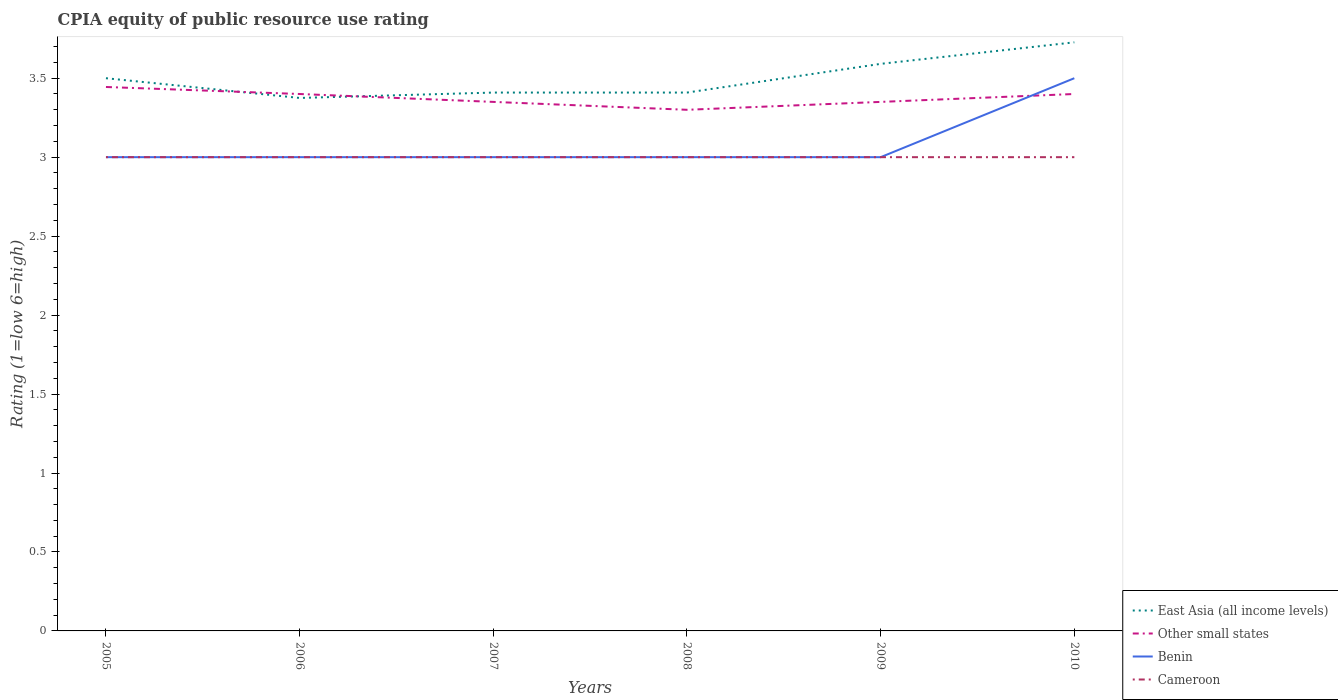How many different coloured lines are there?
Provide a short and direct response. 4. Does the line corresponding to Cameroon intersect with the line corresponding to Benin?
Give a very brief answer. Yes. Is the number of lines equal to the number of legend labels?
Your answer should be compact. Yes. In which year was the CPIA rating in East Asia (all income levels) maximum?
Offer a terse response. 2006. What is the difference between the highest and the second highest CPIA rating in Other small states?
Provide a short and direct response. 0.14. Is the CPIA rating in Cameroon strictly greater than the CPIA rating in East Asia (all income levels) over the years?
Your answer should be compact. Yes. What is the difference between two consecutive major ticks on the Y-axis?
Provide a short and direct response. 0.5. Are the values on the major ticks of Y-axis written in scientific E-notation?
Your response must be concise. No. How many legend labels are there?
Offer a terse response. 4. How are the legend labels stacked?
Give a very brief answer. Vertical. What is the title of the graph?
Make the answer very short. CPIA equity of public resource use rating. Does "Thailand" appear as one of the legend labels in the graph?
Your answer should be compact. No. What is the label or title of the X-axis?
Offer a very short reply. Years. What is the label or title of the Y-axis?
Your answer should be compact. Rating (1=low 6=high). What is the Rating (1=low 6=high) of Other small states in 2005?
Your answer should be compact. 3.44. What is the Rating (1=low 6=high) in East Asia (all income levels) in 2006?
Offer a very short reply. 3.38. What is the Rating (1=low 6=high) in Cameroon in 2006?
Offer a terse response. 3. What is the Rating (1=low 6=high) of East Asia (all income levels) in 2007?
Your answer should be very brief. 3.41. What is the Rating (1=low 6=high) in Other small states in 2007?
Offer a very short reply. 3.35. What is the Rating (1=low 6=high) of Cameroon in 2007?
Ensure brevity in your answer.  3. What is the Rating (1=low 6=high) in East Asia (all income levels) in 2008?
Give a very brief answer. 3.41. What is the Rating (1=low 6=high) of Other small states in 2008?
Ensure brevity in your answer.  3.3. What is the Rating (1=low 6=high) in Benin in 2008?
Offer a terse response. 3. What is the Rating (1=low 6=high) in Cameroon in 2008?
Your answer should be compact. 3. What is the Rating (1=low 6=high) of East Asia (all income levels) in 2009?
Provide a short and direct response. 3.59. What is the Rating (1=low 6=high) of Other small states in 2009?
Keep it short and to the point. 3.35. What is the Rating (1=low 6=high) in Cameroon in 2009?
Offer a terse response. 3. What is the Rating (1=low 6=high) in East Asia (all income levels) in 2010?
Offer a very short reply. 3.73. What is the Rating (1=low 6=high) of Other small states in 2010?
Keep it short and to the point. 3.4. What is the Rating (1=low 6=high) in Cameroon in 2010?
Offer a very short reply. 3. Across all years, what is the maximum Rating (1=low 6=high) in East Asia (all income levels)?
Your answer should be very brief. 3.73. Across all years, what is the maximum Rating (1=low 6=high) of Other small states?
Offer a terse response. 3.44. Across all years, what is the maximum Rating (1=low 6=high) of Cameroon?
Your answer should be compact. 3. Across all years, what is the minimum Rating (1=low 6=high) of East Asia (all income levels)?
Offer a terse response. 3.38. Across all years, what is the minimum Rating (1=low 6=high) of Other small states?
Your answer should be very brief. 3.3. Across all years, what is the minimum Rating (1=low 6=high) of Benin?
Provide a succinct answer. 3. What is the total Rating (1=low 6=high) of East Asia (all income levels) in the graph?
Your answer should be compact. 21.01. What is the total Rating (1=low 6=high) in Other small states in the graph?
Your answer should be very brief. 20.24. What is the total Rating (1=low 6=high) of Benin in the graph?
Your response must be concise. 18.5. What is the total Rating (1=low 6=high) in Cameroon in the graph?
Keep it short and to the point. 18. What is the difference between the Rating (1=low 6=high) in East Asia (all income levels) in 2005 and that in 2006?
Provide a succinct answer. 0.12. What is the difference between the Rating (1=low 6=high) of Other small states in 2005 and that in 2006?
Ensure brevity in your answer.  0.04. What is the difference between the Rating (1=low 6=high) of East Asia (all income levels) in 2005 and that in 2007?
Give a very brief answer. 0.09. What is the difference between the Rating (1=low 6=high) in Other small states in 2005 and that in 2007?
Offer a terse response. 0.09. What is the difference between the Rating (1=low 6=high) of Benin in 2005 and that in 2007?
Provide a short and direct response. 0. What is the difference between the Rating (1=low 6=high) of Cameroon in 2005 and that in 2007?
Offer a very short reply. 0. What is the difference between the Rating (1=low 6=high) in East Asia (all income levels) in 2005 and that in 2008?
Ensure brevity in your answer.  0.09. What is the difference between the Rating (1=low 6=high) in Other small states in 2005 and that in 2008?
Your response must be concise. 0.14. What is the difference between the Rating (1=low 6=high) in Benin in 2005 and that in 2008?
Offer a terse response. 0. What is the difference between the Rating (1=low 6=high) of East Asia (all income levels) in 2005 and that in 2009?
Provide a short and direct response. -0.09. What is the difference between the Rating (1=low 6=high) in Other small states in 2005 and that in 2009?
Provide a short and direct response. 0.09. What is the difference between the Rating (1=low 6=high) in East Asia (all income levels) in 2005 and that in 2010?
Provide a short and direct response. -0.23. What is the difference between the Rating (1=low 6=high) of Other small states in 2005 and that in 2010?
Your answer should be compact. 0.04. What is the difference between the Rating (1=low 6=high) of Cameroon in 2005 and that in 2010?
Offer a terse response. 0. What is the difference between the Rating (1=low 6=high) of East Asia (all income levels) in 2006 and that in 2007?
Offer a terse response. -0.03. What is the difference between the Rating (1=low 6=high) of Benin in 2006 and that in 2007?
Make the answer very short. 0. What is the difference between the Rating (1=low 6=high) of Cameroon in 2006 and that in 2007?
Give a very brief answer. 0. What is the difference between the Rating (1=low 6=high) in East Asia (all income levels) in 2006 and that in 2008?
Your response must be concise. -0.03. What is the difference between the Rating (1=low 6=high) in Other small states in 2006 and that in 2008?
Make the answer very short. 0.1. What is the difference between the Rating (1=low 6=high) of Benin in 2006 and that in 2008?
Your response must be concise. 0. What is the difference between the Rating (1=low 6=high) in East Asia (all income levels) in 2006 and that in 2009?
Your answer should be compact. -0.22. What is the difference between the Rating (1=low 6=high) of Other small states in 2006 and that in 2009?
Give a very brief answer. 0.05. What is the difference between the Rating (1=low 6=high) in Benin in 2006 and that in 2009?
Keep it short and to the point. 0. What is the difference between the Rating (1=low 6=high) in Cameroon in 2006 and that in 2009?
Offer a very short reply. 0. What is the difference between the Rating (1=low 6=high) of East Asia (all income levels) in 2006 and that in 2010?
Give a very brief answer. -0.35. What is the difference between the Rating (1=low 6=high) of East Asia (all income levels) in 2007 and that in 2009?
Your answer should be compact. -0.18. What is the difference between the Rating (1=low 6=high) of Other small states in 2007 and that in 2009?
Provide a short and direct response. 0. What is the difference between the Rating (1=low 6=high) in East Asia (all income levels) in 2007 and that in 2010?
Offer a terse response. -0.32. What is the difference between the Rating (1=low 6=high) of Benin in 2007 and that in 2010?
Offer a very short reply. -0.5. What is the difference between the Rating (1=low 6=high) in East Asia (all income levels) in 2008 and that in 2009?
Keep it short and to the point. -0.18. What is the difference between the Rating (1=low 6=high) of Other small states in 2008 and that in 2009?
Offer a terse response. -0.05. What is the difference between the Rating (1=low 6=high) of Benin in 2008 and that in 2009?
Keep it short and to the point. 0. What is the difference between the Rating (1=low 6=high) in East Asia (all income levels) in 2008 and that in 2010?
Your answer should be very brief. -0.32. What is the difference between the Rating (1=low 6=high) of Other small states in 2008 and that in 2010?
Provide a short and direct response. -0.1. What is the difference between the Rating (1=low 6=high) in East Asia (all income levels) in 2009 and that in 2010?
Keep it short and to the point. -0.14. What is the difference between the Rating (1=low 6=high) of Benin in 2009 and that in 2010?
Make the answer very short. -0.5. What is the difference between the Rating (1=low 6=high) in Cameroon in 2009 and that in 2010?
Your answer should be compact. 0. What is the difference between the Rating (1=low 6=high) in Other small states in 2005 and the Rating (1=low 6=high) in Benin in 2006?
Give a very brief answer. 0.44. What is the difference between the Rating (1=low 6=high) of Other small states in 2005 and the Rating (1=low 6=high) of Cameroon in 2006?
Make the answer very short. 0.44. What is the difference between the Rating (1=low 6=high) of Benin in 2005 and the Rating (1=low 6=high) of Cameroon in 2006?
Your answer should be compact. 0. What is the difference between the Rating (1=low 6=high) in East Asia (all income levels) in 2005 and the Rating (1=low 6=high) in Other small states in 2007?
Give a very brief answer. 0.15. What is the difference between the Rating (1=low 6=high) of East Asia (all income levels) in 2005 and the Rating (1=low 6=high) of Cameroon in 2007?
Ensure brevity in your answer.  0.5. What is the difference between the Rating (1=low 6=high) in Other small states in 2005 and the Rating (1=low 6=high) in Benin in 2007?
Your response must be concise. 0.44. What is the difference between the Rating (1=low 6=high) of Other small states in 2005 and the Rating (1=low 6=high) of Cameroon in 2007?
Your response must be concise. 0.44. What is the difference between the Rating (1=low 6=high) in East Asia (all income levels) in 2005 and the Rating (1=low 6=high) in Cameroon in 2008?
Offer a terse response. 0.5. What is the difference between the Rating (1=low 6=high) in Other small states in 2005 and the Rating (1=low 6=high) in Benin in 2008?
Provide a succinct answer. 0.44. What is the difference between the Rating (1=low 6=high) in Other small states in 2005 and the Rating (1=low 6=high) in Cameroon in 2008?
Your response must be concise. 0.44. What is the difference between the Rating (1=low 6=high) in Benin in 2005 and the Rating (1=low 6=high) in Cameroon in 2008?
Keep it short and to the point. 0. What is the difference between the Rating (1=low 6=high) in East Asia (all income levels) in 2005 and the Rating (1=low 6=high) in Benin in 2009?
Keep it short and to the point. 0.5. What is the difference between the Rating (1=low 6=high) of Other small states in 2005 and the Rating (1=low 6=high) of Benin in 2009?
Your answer should be compact. 0.44. What is the difference between the Rating (1=low 6=high) of Other small states in 2005 and the Rating (1=low 6=high) of Cameroon in 2009?
Your answer should be compact. 0.44. What is the difference between the Rating (1=low 6=high) in East Asia (all income levels) in 2005 and the Rating (1=low 6=high) in Benin in 2010?
Provide a short and direct response. 0. What is the difference between the Rating (1=low 6=high) of East Asia (all income levels) in 2005 and the Rating (1=low 6=high) of Cameroon in 2010?
Give a very brief answer. 0.5. What is the difference between the Rating (1=low 6=high) in Other small states in 2005 and the Rating (1=low 6=high) in Benin in 2010?
Provide a short and direct response. -0.06. What is the difference between the Rating (1=low 6=high) in Other small states in 2005 and the Rating (1=low 6=high) in Cameroon in 2010?
Provide a succinct answer. 0.44. What is the difference between the Rating (1=low 6=high) of Benin in 2005 and the Rating (1=low 6=high) of Cameroon in 2010?
Your answer should be very brief. 0. What is the difference between the Rating (1=low 6=high) in East Asia (all income levels) in 2006 and the Rating (1=low 6=high) in Other small states in 2007?
Ensure brevity in your answer.  0.03. What is the difference between the Rating (1=low 6=high) in East Asia (all income levels) in 2006 and the Rating (1=low 6=high) in Cameroon in 2007?
Make the answer very short. 0.38. What is the difference between the Rating (1=low 6=high) of Other small states in 2006 and the Rating (1=low 6=high) of Benin in 2007?
Your response must be concise. 0.4. What is the difference between the Rating (1=low 6=high) of East Asia (all income levels) in 2006 and the Rating (1=low 6=high) of Other small states in 2008?
Your response must be concise. 0.07. What is the difference between the Rating (1=low 6=high) of East Asia (all income levels) in 2006 and the Rating (1=low 6=high) of Cameroon in 2008?
Your answer should be compact. 0.38. What is the difference between the Rating (1=low 6=high) of Other small states in 2006 and the Rating (1=low 6=high) of Benin in 2008?
Make the answer very short. 0.4. What is the difference between the Rating (1=low 6=high) in East Asia (all income levels) in 2006 and the Rating (1=low 6=high) in Other small states in 2009?
Offer a very short reply. 0.03. What is the difference between the Rating (1=low 6=high) in East Asia (all income levels) in 2006 and the Rating (1=low 6=high) in Benin in 2009?
Provide a short and direct response. 0.38. What is the difference between the Rating (1=low 6=high) of East Asia (all income levels) in 2006 and the Rating (1=low 6=high) of Cameroon in 2009?
Ensure brevity in your answer.  0.38. What is the difference between the Rating (1=low 6=high) in East Asia (all income levels) in 2006 and the Rating (1=low 6=high) in Other small states in 2010?
Provide a succinct answer. -0.03. What is the difference between the Rating (1=low 6=high) in East Asia (all income levels) in 2006 and the Rating (1=low 6=high) in Benin in 2010?
Provide a succinct answer. -0.12. What is the difference between the Rating (1=low 6=high) of Other small states in 2006 and the Rating (1=low 6=high) of Cameroon in 2010?
Give a very brief answer. 0.4. What is the difference between the Rating (1=low 6=high) in East Asia (all income levels) in 2007 and the Rating (1=low 6=high) in Other small states in 2008?
Offer a terse response. 0.11. What is the difference between the Rating (1=low 6=high) in East Asia (all income levels) in 2007 and the Rating (1=low 6=high) in Benin in 2008?
Provide a succinct answer. 0.41. What is the difference between the Rating (1=low 6=high) in East Asia (all income levels) in 2007 and the Rating (1=low 6=high) in Cameroon in 2008?
Give a very brief answer. 0.41. What is the difference between the Rating (1=low 6=high) in Other small states in 2007 and the Rating (1=low 6=high) in Cameroon in 2008?
Offer a very short reply. 0.35. What is the difference between the Rating (1=low 6=high) of East Asia (all income levels) in 2007 and the Rating (1=low 6=high) of Other small states in 2009?
Keep it short and to the point. 0.06. What is the difference between the Rating (1=low 6=high) in East Asia (all income levels) in 2007 and the Rating (1=low 6=high) in Benin in 2009?
Offer a terse response. 0.41. What is the difference between the Rating (1=low 6=high) of East Asia (all income levels) in 2007 and the Rating (1=low 6=high) of Cameroon in 2009?
Your answer should be very brief. 0.41. What is the difference between the Rating (1=low 6=high) of Other small states in 2007 and the Rating (1=low 6=high) of Cameroon in 2009?
Your answer should be very brief. 0.35. What is the difference between the Rating (1=low 6=high) in Benin in 2007 and the Rating (1=low 6=high) in Cameroon in 2009?
Offer a terse response. 0. What is the difference between the Rating (1=low 6=high) in East Asia (all income levels) in 2007 and the Rating (1=low 6=high) in Other small states in 2010?
Your answer should be very brief. 0.01. What is the difference between the Rating (1=low 6=high) in East Asia (all income levels) in 2007 and the Rating (1=low 6=high) in Benin in 2010?
Offer a terse response. -0.09. What is the difference between the Rating (1=low 6=high) in East Asia (all income levels) in 2007 and the Rating (1=low 6=high) in Cameroon in 2010?
Provide a succinct answer. 0.41. What is the difference between the Rating (1=low 6=high) in Other small states in 2007 and the Rating (1=low 6=high) in Benin in 2010?
Your answer should be compact. -0.15. What is the difference between the Rating (1=low 6=high) of Benin in 2007 and the Rating (1=low 6=high) of Cameroon in 2010?
Your answer should be very brief. 0. What is the difference between the Rating (1=low 6=high) of East Asia (all income levels) in 2008 and the Rating (1=low 6=high) of Other small states in 2009?
Provide a succinct answer. 0.06. What is the difference between the Rating (1=low 6=high) in East Asia (all income levels) in 2008 and the Rating (1=low 6=high) in Benin in 2009?
Provide a succinct answer. 0.41. What is the difference between the Rating (1=low 6=high) in East Asia (all income levels) in 2008 and the Rating (1=low 6=high) in Cameroon in 2009?
Your response must be concise. 0.41. What is the difference between the Rating (1=low 6=high) of Benin in 2008 and the Rating (1=low 6=high) of Cameroon in 2009?
Provide a short and direct response. 0. What is the difference between the Rating (1=low 6=high) of East Asia (all income levels) in 2008 and the Rating (1=low 6=high) of Other small states in 2010?
Make the answer very short. 0.01. What is the difference between the Rating (1=low 6=high) in East Asia (all income levels) in 2008 and the Rating (1=low 6=high) in Benin in 2010?
Provide a short and direct response. -0.09. What is the difference between the Rating (1=low 6=high) in East Asia (all income levels) in 2008 and the Rating (1=low 6=high) in Cameroon in 2010?
Ensure brevity in your answer.  0.41. What is the difference between the Rating (1=low 6=high) of East Asia (all income levels) in 2009 and the Rating (1=low 6=high) of Other small states in 2010?
Keep it short and to the point. 0.19. What is the difference between the Rating (1=low 6=high) in East Asia (all income levels) in 2009 and the Rating (1=low 6=high) in Benin in 2010?
Provide a short and direct response. 0.09. What is the difference between the Rating (1=low 6=high) in East Asia (all income levels) in 2009 and the Rating (1=low 6=high) in Cameroon in 2010?
Ensure brevity in your answer.  0.59. What is the difference between the Rating (1=low 6=high) of Other small states in 2009 and the Rating (1=low 6=high) of Cameroon in 2010?
Your answer should be very brief. 0.35. What is the difference between the Rating (1=low 6=high) of Benin in 2009 and the Rating (1=low 6=high) of Cameroon in 2010?
Your answer should be compact. 0. What is the average Rating (1=low 6=high) of East Asia (all income levels) per year?
Keep it short and to the point. 3.5. What is the average Rating (1=low 6=high) of Other small states per year?
Make the answer very short. 3.37. What is the average Rating (1=low 6=high) in Benin per year?
Keep it short and to the point. 3.08. In the year 2005, what is the difference between the Rating (1=low 6=high) of East Asia (all income levels) and Rating (1=low 6=high) of Other small states?
Provide a short and direct response. 0.06. In the year 2005, what is the difference between the Rating (1=low 6=high) of East Asia (all income levels) and Rating (1=low 6=high) of Benin?
Ensure brevity in your answer.  0.5. In the year 2005, what is the difference between the Rating (1=low 6=high) in East Asia (all income levels) and Rating (1=low 6=high) in Cameroon?
Offer a terse response. 0.5. In the year 2005, what is the difference between the Rating (1=low 6=high) in Other small states and Rating (1=low 6=high) in Benin?
Your answer should be compact. 0.44. In the year 2005, what is the difference between the Rating (1=low 6=high) of Other small states and Rating (1=low 6=high) of Cameroon?
Ensure brevity in your answer.  0.44. In the year 2006, what is the difference between the Rating (1=low 6=high) of East Asia (all income levels) and Rating (1=low 6=high) of Other small states?
Provide a succinct answer. -0.03. In the year 2006, what is the difference between the Rating (1=low 6=high) in East Asia (all income levels) and Rating (1=low 6=high) in Cameroon?
Make the answer very short. 0.38. In the year 2006, what is the difference between the Rating (1=low 6=high) in Other small states and Rating (1=low 6=high) in Benin?
Ensure brevity in your answer.  0.4. In the year 2006, what is the difference between the Rating (1=low 6=high) in Other small states and Rating (1=low 6=high) in Cameroon?
Make the answer very short. 0.4. In the year 2006, what is the difference between the Rating (1=low 6=high) in Benin and Rating (1=low 6=high) in Cameroon?
Make the answer very short. 0. In the year 2007, what is the difference between the Rating (1=low 6=high) of East Asia (all income levels) and Rating (1=low 6=high) of Other small states?
Offer a terse response. 0.06. In the year 2007, what is the difference between the Rating (1=low 6=high) of East Asia (all income levels) and Rating (1=low 6=high) of Benin?
Provide a short and direct response. 0.41. In the year 2007, what is the difference between the Rating (1=low 6=high) in East Asia (all income levels) and Rating (1=low 6=high) in Cameroon?
Offer a terse response. 0.41. In the year 2007, what is the difference between the Rating (1=low 6=high) of Other small states and Rating (1=low 6=high) of Benin?
Provide a short and direct response. 0.35. In the year 2007, what is the difference between the Rating (1=low 6=high) of Other small states and Rating (1=low 6=high) of Cameroon?
Give a very brief answer. 0.35. In the year 2007, what is the difference between the Rating (1=low 6=high) of Benin and Rating (1=low 6=high) of Cameroon?
Provide a succinct answer. 0. In the year 2008, what is the difference between the Rating (1=low 6=high) in East Asia (all income levels) and Rating (1=low 6=high) in Other small states?
Provide a short and direct response. 0.11. In the year 2008, what is the difference between the Rating (1=low 6=high) of East Asia (all income levels) and Rating (1=low 6=high) of Benin?
Your answer should be compact. 0.41. In the year 2008, what is the difference between the Rating (1=low 6=high) of East Asia (all income levels) and Rating (1=low 6=high) of Cameroon?
Ensure brevity in your answer.  0.41. In the year 2008, what is the difference between the Rating (1=low 6=high) in Other small states and Rating (1=low 6=high) in Cameroon?
Give a very brief answer. 0.3. In the year 2009, what is the difference between the Rating (1=low 6=high) in East Asia (all income levels) and Rating (1=low 6=high) in Other small states?
Offer a very short reply. 0.24. In the year 2009, what is the difference between the Rating (1=low 6=high) of East Asia (all income levels) and Rating (1=low 6=high) of Benin?
Give a very brief answer. 0.59. In the year 2009, what is the difference between the Rating (1=low 6=high) of East Asia (all income levels) and Rating (1=low 6=high) of Cameroon?
Offer a terse response. 0.59. In the year 2010, what is the difference between the Rating (1=low 6=high) in East Asia (all income levels) and Rating (1=low 6=high) in Other small states?
Offer a very short reply. 0.33. In the year 2010, what is the difference between the Rating (1=low 6=high) in East Asia (all income levels) and Rating (1=low 6=high) in Benin?
Provide a short and direct response. 0.23. In the year 2010, what is the difference between the Rating (1=low 6=high) of East Asia (all income levels) and Rating (1=low 6=high) of Cameroon?
Provide a short and direct response. 0.73. In the year 2010, what is the difference between the Rating (1=low 6=high) of Other small states and Rating (1=low 6=high) of Benin?
Ensure brevity in your answer.  -0.1. In the year 2010, what is the difference between the Rating (1=low 6=high) in Other small states and Rating (1=low 6=high) in Cameroon?
Provide a succinct answer. 0.4. What is the ratio of the Rating (1=low 6=high) in East Asia (all income levels) in 2005 to that in 2006?
Keep it short and to the point. 1.04. What is the ratio of the Rating (1=low 6=high) of Other small states in 2005 to that in 2006?
Provide a succinct answer. 1.01. What is the ratio of the Rating (1=low 6=high) of Benin in 2005 to that in 2006?
Ensure brevity in your answer.  1. What is the ratio of the Rating (1=low 6=high) in East Asia (all income levels) in 2005 to that in 2007?
Your answer should be very brief. 1.03. What is the ratio of the Rating (1=low 6=high) in Other small states in 2005 to that in 2007?
Offer a terse response. 1.03. What is the ratio of the Rating (1=low 6=high) of Benin in 2005 to that in 2007?
Your answer should be compact. 1. What is the ratio of the Rating (1=low 6=high) of Cameroon in 2005 to that in 2007?
Provide a short and direct response. 1. What is the ratio of the Rating (1=low 6=high) of East Asia (all income levels) in 2005 to that in 2008?
Your response must be concise. 1.03. What is the ratio of the Rating (1=low 6=high) in Other small states in 2005 to that in 2008?
Your answer should be very brief. 1.04. What is the ratio of the Rating (1=low 6=high) in East Asia (all income levels) in 2005 to that in 2009?
Make the answer very short. 0.97. What is the ratio of the Rating (1=low 6=high) in Other small states in 2005 to that in 2009?
Provide a succinct answer. 1.03. What is the ratio of the Rating (1=low 6=high) in East Asia (all income levels) in 2005 to that in 2010?
Offer a very short reply. 0.94. What is the ratio of the Rating (1=low 6=high) in Other small states in 2005 to that in 2010?
Your answer should be compact. 1.01. What is the ratio of the Rating (1=low 6=high) in Benin in 2005 to that in 2010?
Keep it short and to the point. 0.86. What is the ratio of the Rating (1=low 6=high) of Other small states in 2006 to that in 2007?
Make the answer very short. 1.01. What is the ratio of the Rating (1=low 6=high) in Benin in 2006 to that in 2007?
Make the answer very short. 1. What is the ratio of the Rating (1=low 6=high) of Cameroon in 2006 to that in 2007?
Offer a terse response. 1. What is the ratio of the Rating (1=low 6=high) in East Asia (all income levels) in 2006 to that in 2008?
Offer a terse response. 0.99. What is the ratio of the Rating (1=low 6=high) in Other small states in 2006 to that in 2008?
Your response must be concise. 1.03. What is the ratio of the Rating (1=low 6=high) in Benin in 2006 to that in 2008?
Offer a terse response. 1. What is the ratio of the Rating (1=low 6=high) in East Asia (all income levels) in 2006 to that in 2009?
Keep it short and to the point. 0.94. What is the ratio of the Rating (1=low 6=high) of Other small states in 2006 to that in 2009?
Give a very brief answer. 1.01. What is the ratio of the Rating (1=low 6=high) of Benin in 2006 to that in 2009?
Your answer should be very brief. 1. What is the ratio of the Rating (1=low 6=high) of Cameroon in 2006 to that in 2009?
Provide a succinct answer. 1. What is the ratio of the Rating (1=low 6=high) of East Asia (all income levels) in 2006 to that in 2010?
Ensure brevity in your answer.  0.91. What is the ratio of the Rating (1=low 6=high) in Cameroon in 2006 to that in 2010?
Offer a very short reply. 1. What is the ratio of the Rating (1=low 6=high) in Other small states in 2007 to that in 2008?
Offer a terse response. 1.02. What is the ratio of the Rating (1=low 6=high) in Benin in 2007 to that in 2008?
Offer a very short reply. 1. What is the ratio of the Rating (1=low 6=high) of East Asia (all income levels) in 2007 to that in 2009?
Offer a terse response. 0.95. What is the ratio of the Rating (1=low 6=high) of Other small states in 2007 to that in 2009?
Keep it short and to the point. 1. What is the ratio of the Rating (1=low 6=high) of East Asia (all income levels) in 2007 to that in 2010?
Offer a very short reply. 0.91. What is the ratio of the Rating (1=low 6=high) in Other small states in 2007 to that in 2010?
Your answer should be compact. 0.99. What is the ratio of the Rating (1=low 6=high) of East Asia (all income levels) in 2008 to that in 2009?
Give a very brief answer. 0.95. What is the ratio of the Rating (1=low 6=high) of Other small states in 2008 to that in 2009?
Ensure brevity in your answer.  0.99. What is the ratio of the Rating (1=low 6=high) in East Asia (all income levels) in 2008 to that in 2010?
Ensure brevity in your answer.  0.91. What is the ratio of the Rating (1=low 6=high) of Other small states in 2008 to that in 2010?
Make the answer very short. 0.97. What is the ratio of the Rating (1=low 6=high) in Benin in 2008 to that in 2010?
Your response must be concise. 0.86. What is the ratio of the Rating (1=low 6=high) in Cameroon in 2008 to that in 2010?
Give a very brief answer. 1. What is the ratio of the Rating (1=low 6=high) in East Asia (all income levels) in 2009 to that in 2010?
Provide a succinct answer. 0.96. What is the ratio of the Rating (1=low 6=high) of Cameroon in 2009 to that in 2010?
Your answer should be compact. 1. What is the difference between the highest and the second highest Rating (1=low 6=high) in East Asia (all income levels)?
Make the answer very short. 0.14. What is the difference between the highest and the second highest Rating (1=low 6=high) of Other small states?
Offer a terse response. 0.04. What is the difference between the highest and the second highest Rating (1=low 6=high) in Cameroon?
Make the answer very short. 0. What is the difference between the highest and the lowest Rating (1=low 6=high) in East Asia (all income levels)?
Offer a very short reply. 0.35. What is the difference between the highest and the lowest Rating (1=low 6=high) in Other small states?
Make the answer very short. 0.14. What is the difference between the highest and the lowest Rating (1=low 6=high) in Benin?
Your answer should be compact. 0.5. What is the difference between the highest and the lowest Rating (1=low 6=high) of Cameroon?
Give a very brief answer. 0. 